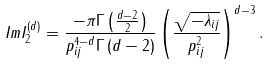Convert formula to latex. <formula><loc_0><loc_0><loc_500><loc_500>I m I _ { 2 } ^ { ( d ) } = \frac { - \pi \Gamma \left ( \frac { d - 2 } { 2 } \right ) } { p _ { i j } ^ { 4 - d } \Gamma \left ( d - 2 \right ) } \left ( \frac { \sqrt { - \lambda _ { i j } } } { p _ { i j } ^ { 2 } } \right ) ^ { d - 3 } .</formula> 